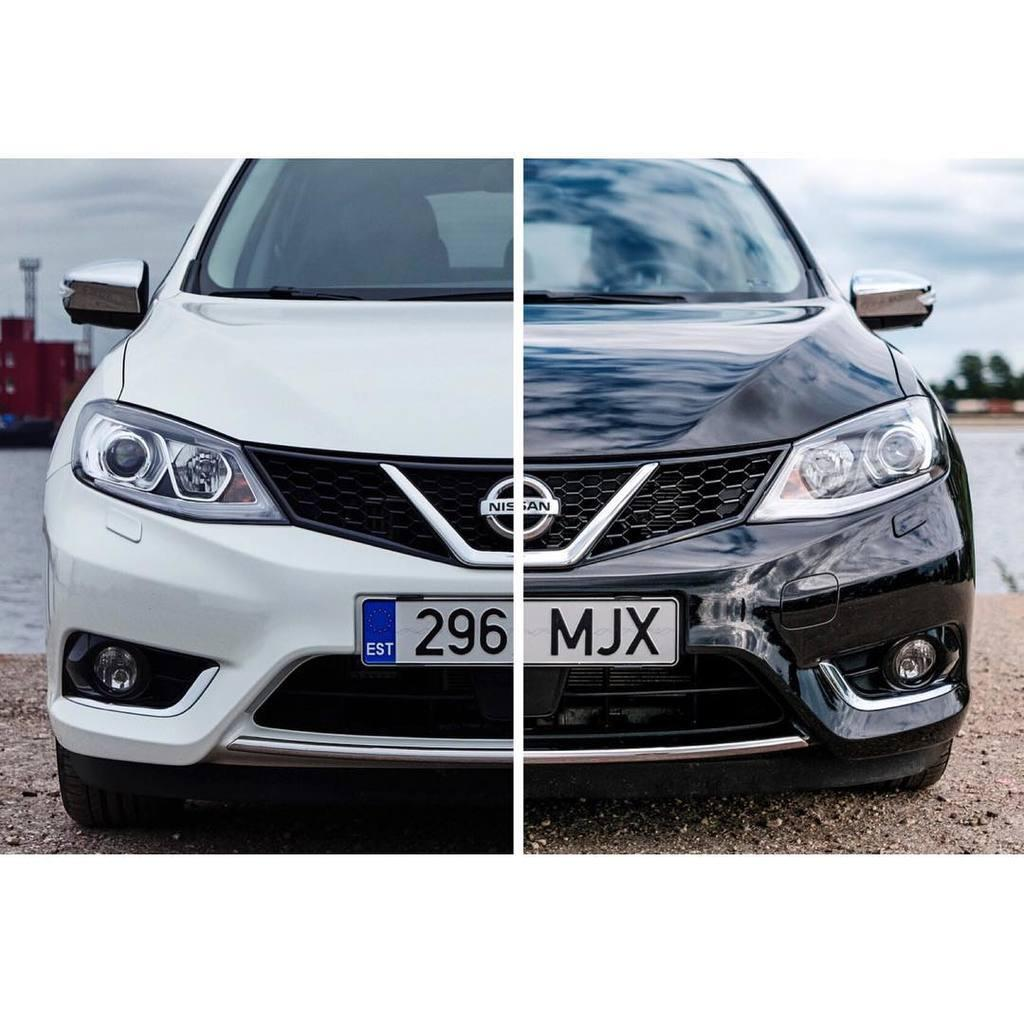How many vehicles can be seen in the image? There are two vehicles in the image. What else is visible in the image besides the vehicles? Trees and the sky are visible in the image. What type of cable is connecting the two vehicles in the image? There is no cable connecting the two vehicles in the image; they are separate entities. 